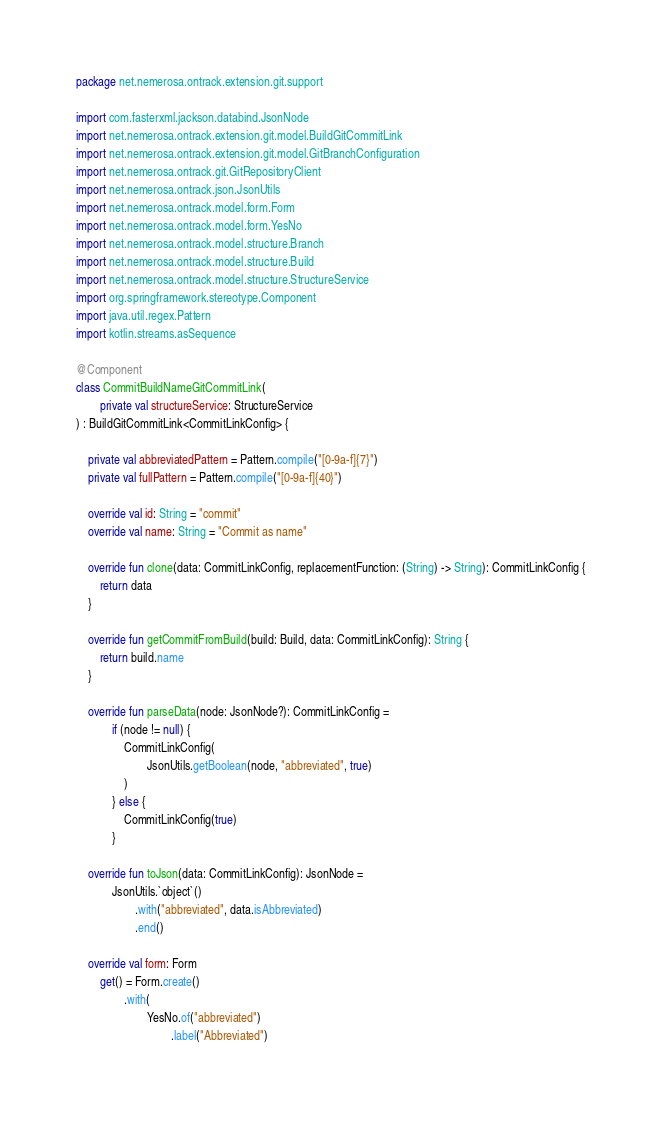Convert code to text. <code><loc_0><loc_0><loc_500><loc_500><_Kotlin_>package net.nemerosa.ontrack.extension.git.support

import com.fasterxml.jackson.databind.JsonNode
import net.nemerosa.ontrack.extension.git.model.BuildGitCommitLink
import net.nemerosa.ontrack.extension.git.model.GitBranchConfiguration
import net.nemerosa.ontrack.git.GitRepositoryClient
import net.nemerosa.ontrack.json.JsonUtils
import net.nemerosa.ontrack.model.form.Form
import net.nemerosa.ontrack.model.form.YesNo
import net.nemerosa.ontrack.model.structure.Branch
import net.nemerosa.ontrack.model.structure.Build
import net.nemerosa.ontrack.model.structure.StructureService
import org.springframework.stereotype.Component
import java.util.regex.Pattern
import kotlin.streams.asSequence

@Component
class CommitBuildNameGitCommitLink(
        private val structureService: StructureService
) : BuildGitCommitLink<CommitLinkConfig> {

    private val abbreviatedPattern = Pattern.compile("[0-9a-f]{7}")
    private val fullPattern = Pattern.compile("[0-9a-f]{40}")

    override val id: String = "commit"
    override val name: String = "Commit as name"

    override fun clone(data: CommitLinkConfig, replacementFunction: (String) -> String): CommitLinkConfig {
        return data
    }

    override fun getCommitFromBuild(build: Build, data: CommitLinkConfig): String {
        return build.name
    }

    override fun parseData(node: JsonNode?): CommitLinkConfig =
            if (node != null) {
                CommitLinkConfig(
                        JsonUtils.getBoolean(node, "abbreviated", true)
                )
            } else {
                CommitLinkConfig(true)
            }

    override fun toJson(data: CommitLinkConfig): JsonNode =
            JsonUtils.`object`()
                    .with("abbreviated", data.isAbbreviated)
                    .end()

    override val form: Form
        get() = Form.create()
                .with(
                        YesNo.of("abbreviated")
                                .label("Abbreviated")</code> 